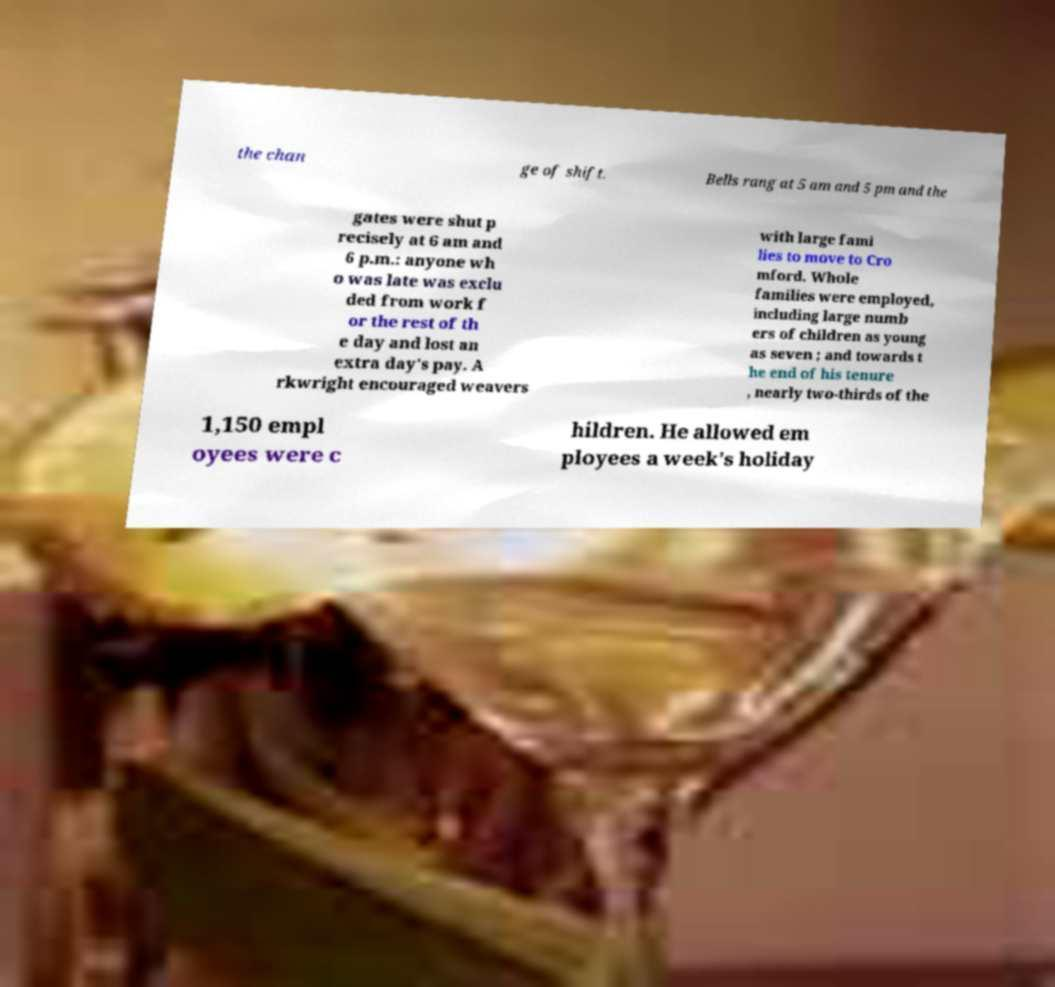For documentation purposes, I need the text within this image transcribed. Could you provide that? the chan ge of shift. Bells rang at 5 am and 5 pm and the gates were shut p recisely at 6 am and 6 p.m.: anyone wh o was late was exclu ded from work f or the rest of th e day and lost an extra day's pay. A rkwright encouraged weavers with large fami lies to move to Cro mford. Whole families were employed, including large numb ers of children as young as seven ; and towards t he end of his tenure , nearly two-thirds of the 1,150 empl oyees were c hildren. He allowed em ployees a week's holiday 